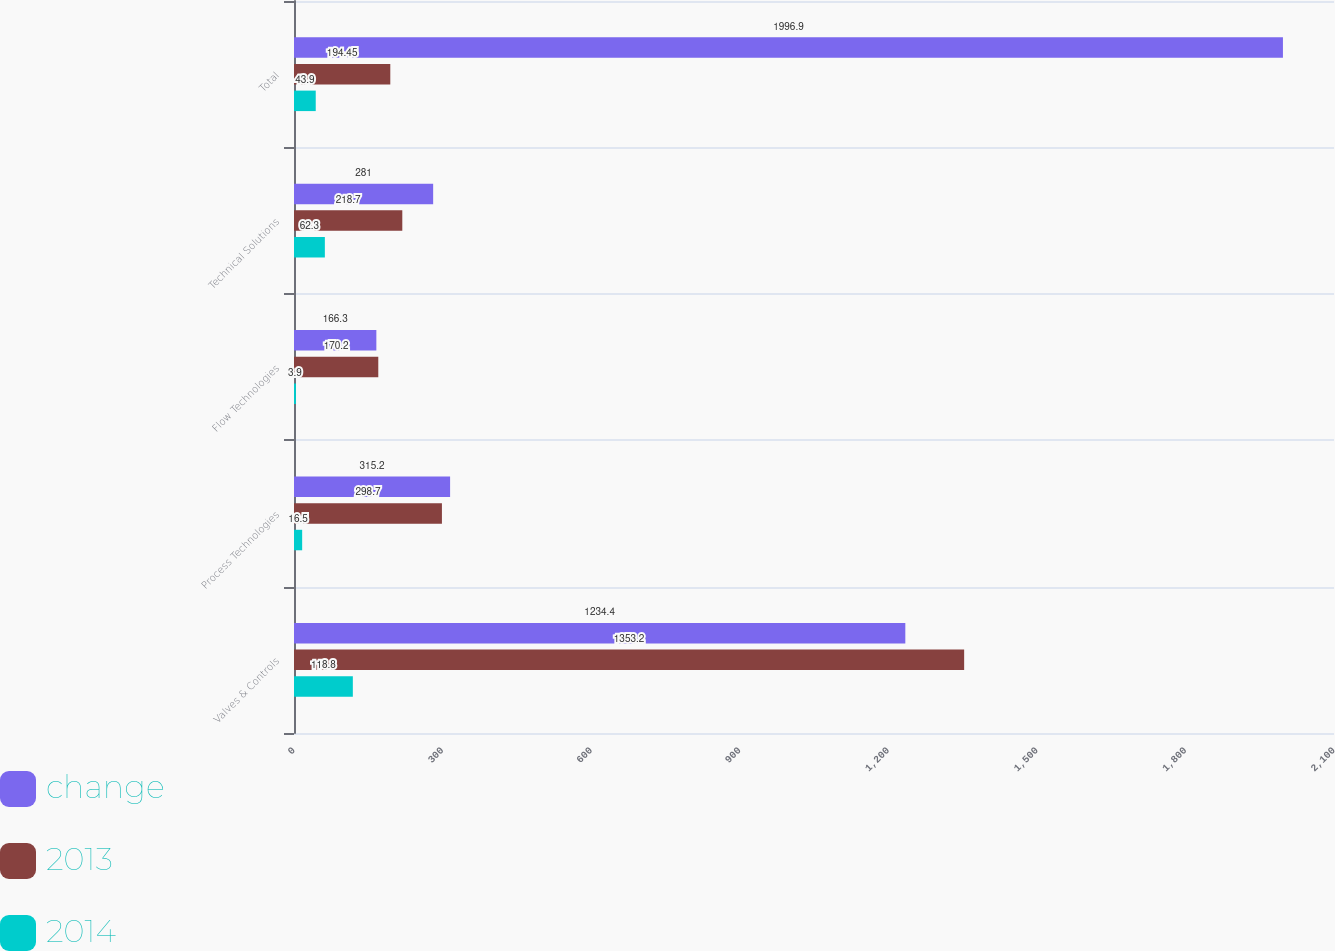Convert chart to OTSL. <chart><loc_0><loc_0><loc_500><loc_500><stacked_bar_chart><ecel><fcel>Valves & Controls<fcel>Process Technologies<fcel>Flow Technologies<fcel>Technical Solutions<fcel>Total<nl><fcel>change<fcel>1234.4<fcel>315.2<fcel>166.3<fcel>281<fcel>1996.9<nl><fcel>2013<fcel>1353.2<fcel>298.7<fcel>170.2<fcel>218.7<fcel>194.45<nl><fcel>2014<fcel>118.8<fcel>16.5<fcel>3.9<fcel>62.3<fcel>43.9<nl></chart> 